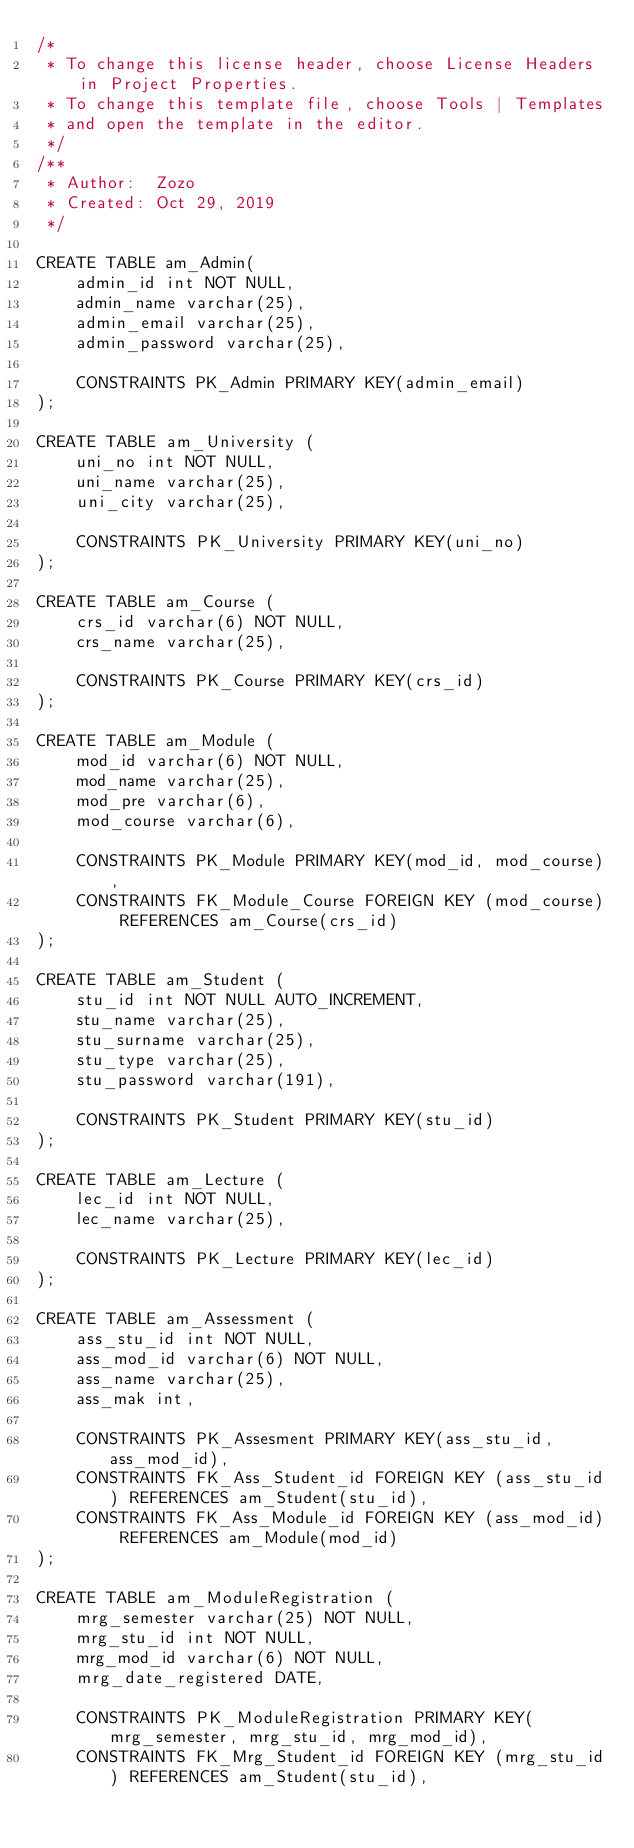<code> <loc_0><loc_0><loc_500><loc_500><_SQL_>/* 
 * To change this license header, choose License Headers in Project Properties.
 * To change this template file, choose Tools | Templates
 * and open the template in the editor.
 */
/**
 * Author:  Zozo
 * Created: Oct 29, 2019
 */

CREATE TABLE am_Admin(
    admin_id int NOT NULL,
    admin_name varchar(25),
    admin_email varchar(25),
    admin_password varchar(25),
	
    CONSTRAINTS PK_Admin PRIMARY KEY(admin_email)
);

CREATE TABLE am_University (
    uni_no int NOT NULL,
    uni_name varchar(25),
    uni_city varchar(25),
	
    CONSTRAINTS PK_University PRIMARY KEY(uni_no)
);

CREATE TABLE am_Course (
    crs_id varchar(6) NOT NULL,
    crs_name varchar(25),
	
    CONSTRAINTS PK_Course PRIMARY KEY(crs_id)
);

CREATE TABLE am_Module (
    mod_id varchar(6) NOT NULL,
    mod_name varchar(25),
    mod_pre varchar(6),
    mod_course varchar(6),

    CONSTRAINTS PK_Module PRIMARY KEY(mod_id, mod_course),
    CONSTRAINTS FK_Module_Course FOREIGN KEY (mod_course) REFERENCES am_Course(crs_id)
);

CREATE TABLE am_Student (
    stu_id int NOT NULL AUTO_INCREMENT,
    stu_name varchar(25),
    stu_surname varchar(25),
    stu_type varchar(25),
    stu_password varchar(191),
	
    CONSTRAINTS PK_Student PRIMARY KEY(stu_id)
);

CREATE TABLE am_Lecture (
    lec_id int NOT NULL,
    lec_name varchar(25),

    CONSTRAINTS PK_Lecture PRIMARY KEY(lec_id)
);

CREATE TABLE am_Assessment (
    ass_stu_id int NOT NULL,
    ass_mod_id varchar(6) NOT NULL,
    ass_name varchar(25),
    ass_mak int,
	
    CONSTRAINTS PK_Assesment PRIMARY KEY(ass_stu_id, ass_mod_id),
    CONSTRAINTS FK_Ass_Student_id FOREIGN KEY (ass_stu_id) REFERENCES am_Student(stu_id),
    CONSTRAINTS FK_Ass_Module_id FOREIGN KEY (ass_mod_id) REFERENCES am_Module(mod_id)
);

CREATE TABLE am_ModuleRegistration (
    mrg_semester varchar(25) NOT NULL,
    mrg_stu_id int NOT NULL,
    mrg_mod_id varchar(6) NOT NULL,
    mrg_date_registered DATE,
	
    CONSTRAINTS PK_ModuleRegistration PRIMARY KEY(mrg_semester, mrg_stu_id, mrg_mod_id),
    CONSTRAINTS FK_Mrg_Student_id FOREIGN KEY (mrg_stu_id) REFERENCES am_Student(stu_id),</code> 